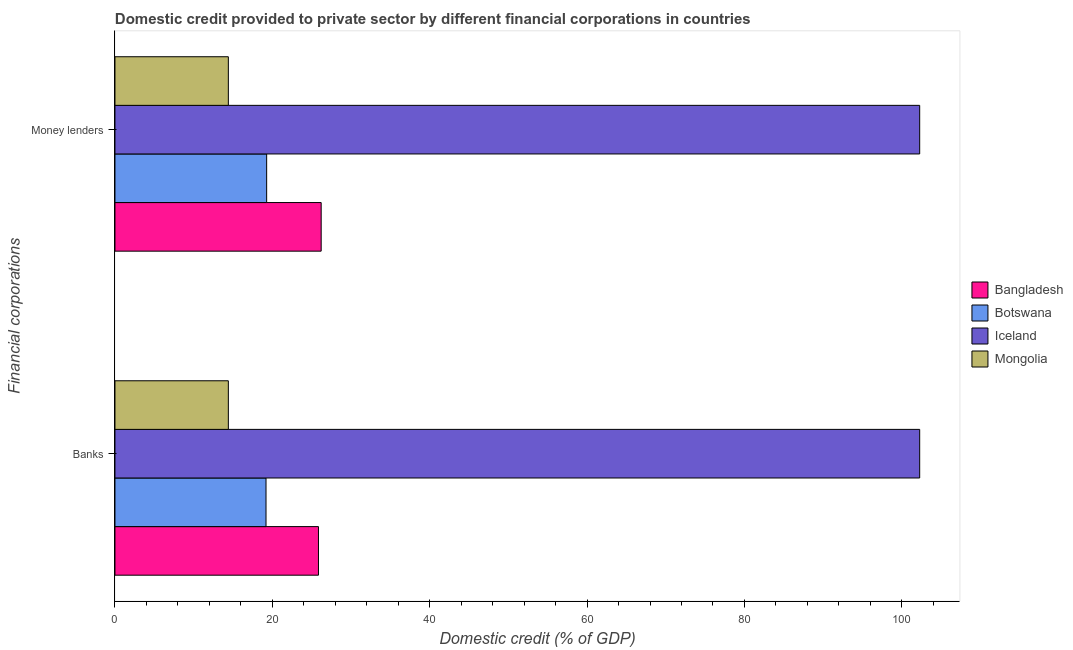How many different coloured bars are there?
Ensure brevity in your answer.  4. Are the number of bars per tick equal to the number of legend labels?
Your response must be concise. Yes. How many bars are there on the 2nd tick from the bottom?
Offer a terse response. 4. What is the label of the 1st group of bars from the top?
Offer a terse response. Money lenders. What is the domestic credit provided by money lenders in Bangladesh?
Your answer should be compact. 26.21. Across all countries, what is the maximum domestic credit provided by money lenders?
Make the answer very short. 102.27. Across all countries, what is the minimum domestic credit provided by money lenders?
Offer a very short reply. 14.41. In which country was the domestic credit provided by banks minimum?
Your response must be concise. Mongolia. What is the total domestic credit provided by banks in the graph?
Ensure brevity in your answer.  161.75. What is the difference between the domestic credit provided by money lenders in Mongolia and that in Iceland?
Your answer should be compact. -87.86. What is the difference between the domestic credit provided by money lenders in Mongolia and the domestic credit provided by banks in Bangladesh?
Your answer should be very brief. -11.45. What is the average domestic credit provided by banks per country?
Your answer should be compact. 40.44. What is the difference between the domestic credit provided by money lenders and domestic credit provided by banks in Botswana?
Make the answer very short. 0.08. In how many countries, is the domestic credit provided by money lenders greater than 80 %?
Your response must be concise. 1. What is the ratio of the domestic credit provided by banks in Iceland to that in Mongolia?
Give a very brief answer. 7.1. Is the domestic credit provided by money lenders in Mongolia less than that in Bangladesh?
Your answer should be very brief. Yes. What does the 3rd bar from the bottom in Money lenders represents?
Your answer should be very brief. Iceland. How many countries are there in the graph?
Provide a short and direct response. 4. What is the difference between two consecutive major ticks on the X-axis?
Your answer should be compact. 20. Are the values on the major ticks of X-axis written in scientific E-notation?
Your response must be concise. No. Does the graph contain any zero values?
Give a very brief answer. No. How many legend labels are there?
Offer a very short reply. 4. How are the legend labels stacked?
Ensure brevity in your answer.  Vertical. What is the title of the graph?
Give a very brief answer. Domestic credit provided to private sector by different financial corporations in countries. What is the label or title of the X-axis?
Your answer should be compact. Domestic credit (% of GDP). What is the label or title of the Y-axis?
Keep it short and to the point. Financial corporations. What is the Domestic credit (% of GDP) in Bangladesh in Banks?
Provide a succinct answer. 25.86. What is the Domestic credit (% of GDP) in Botswana in Banks?
Offer a terse response. 19.2. What is the Domestic credit (% of GDP) in Iceland in Banks?
Provide a short and direct response. 102.27. What is the Domestic credit (% of GDP) of Mongolia in Banks?
Provide a succinct answer. 14.41. What is the Domestic credit (% of GDP) of Bangladesh in Money lenders?
Give a very brief answer. 26.21. What is the Domestic credit (% of GDP) of Botswana in Money lenders?
Provide a succinct answer. 19.28. What is the Domestic credit (% of GDP) in Iceland in Money lenders?
Ensure brevity in your answer.  102.27. What is the Domestic credit (% of GDP) of Mongolia in Money lenders?
Keep it short and to the point. 14.41. Across all Financial corporations, what is the maximum Domestic credit (% of GDP) in Bangladesh?
Provide a short and direct response. 26.21. Across all Financial corporations, what is the maximum Domestic credit (% of GDP) of Botswana?
Your answer should be compact. 19.28. Across all Financial corporations, what is the maximum Domestic credit (% of GDP) in Iceland?
Offer a very short reply. 102.27. Across all Financial corporations, what is the maximum Domestic credit (% of GDP) of Mongolia?
Make the answer very short. 14.41. Across all Financial corporations, what is the minimum Domestic credit (% of GDP) in Bangladesh?
Keep it short and to the point. 25.86. Across all Financial corporations, what is the minimum Domestic credit (% of GDP) of Botswana?
Offer a very short reply. 19.2. Across all Financial corporations, what is the minimum Domestic credit (% of GDP) of Iceland?
Make the answer very short. 102.27. Across all Financial corporations, what is the minimum Domestic credit (% of GDP) in Mongolia?
Your answer should be compact. 14.41. What is the total Domestic credit (% of GDP) of Bangladesh in the graph?
Your response must be concise. 52.07. What is the total Domestic credit (% of GDP) of Botswana in the graph?
Offer a very short reply. 38.48. What is the total Domestic credit (% of GDP) of Iceland in the graph?
Ensure brevity in your answer.  204.55. What is the total Domestic credit (% of GDP) in Mongolia in the graph?
Make the answer very short. 28.82. What is the difference between the Domestic credit (% of GDP) of Bangladesh in Banks and that in Money lenders?
Provide a succinct answer. -0.34. What is the difference between the Domestic credit (% of GDP) of Botswana in Banks and that in Money lenders?
Your response must be concise. -0.08. What is the difference between the Domestic credit (% of GDP) of Mongolia in Banks and that in Money lenders?
Keep it short and to the point. 0. What is the difference between the Domestic credit (% of GDP) in Bangladesh in Banks and the Domestic credit (% of GDP) in Botswana in Money lenders?
Your answer should be very brief. 6.58. What is the difference between the Domestic credit (% of GDP) of Bangladesh in Banks and the Domestic credit (% of GDP) of Iceland in Money lenders?
Offer a very short reply. -76.41. What is the difference between the Domestic credit (% of GDP) of Bangladesh in Banks and the Domestic credit (% of GDP) of Mongolia in Money lenders?
Make the answer very short. 11.45. What is the difference between the Domestic credit (% of GDP) of Botswana in Banks and the Domestic credit (% of GDP) of Iceland in Money lenders?
Provide a succinct answer. -83.08. What is the difference between the Domestic credit (% of GDP) of Botswana in Banks and the Domestic credit (% of GDP) of Mongolia in Money lenders?
Provide a succinct answer. 4.79. What is the difference between the Domestic credit (% of GDP) in Iceland in Banks and the Domestic credit (% of GDP) in Mongolia in Money lenders?
Ensure brevity in your answer.  87.86. What is the average Domestic credit (% of GDP) of Bangladesh per Financial corporations?
Keep it short and to the point. 26.04. What is the average Domestic credit (% of GDP) of Botswana per Financial corporations?
Keep it short and to the point. 19.24. What is the average Domestic credit (% of GDP) in Iceland per Financial corporations?
Ensure brevity in your answer.  102.27. What is the average Domestic credit (% of GDP) in Mongolia per Financial corporations?
Keep it short and to the point. 14.41. What is the difference between the Domestic credit (% of GDP) of Bangladesh and Domestic credit (% of GDP) of Botswana in Banks?
Your answer should be very brief. 6.67. What is the difference between the Domestic credit (% of GDP) in Bangladesh and Domestic credit (% of GDP) in Iceland in Banks?
Provide a succinct answer. -76.41. What is the difference between the Domestic credit (% of GDP) in Bangladesh and Domestic credit (% of GDP) in Mongolia in Banks?
Your answer should be very brief. 11.45. What is the difference between the Domestic credit (% of GDP) of Botswana and Domestic credit (% of GDP) of Iceland in Banks?
Provide a succinct answer. -83.08. What is the difference between the Domestic credit (% of GDP) in Botswana and Domestic credit (% of GDP) in Mongolia in Banks?
Make the answer very short. 4.79. What is the difference between the Domestic credit (% of GDP) in Iceland and Domestic credit (% of GDP) in Mongolia in Banks?
Provide a short and direct response. 87.86. What is the difference between the Domestic credit (% of GDP) in Bangladesh and Domestic credit (% of GDP) in Botswana in Money lenders?
Your response must be concise. 6.93. What is the difference between the Domestic credit (% of GDP) of Bangladesh and Domestic credit (% of GDP) of Iceland in Money lenders?
Provide a succinct answer. -76.07. What is the difference between the Domestic credit (% of GDP) in Bangladesh and Domestic credit (% of GDP) in Mongolia in Money lenders?
Offer a very short reply. 11.8. What is the difference between the Domestic credit (% of GDP) in Botswana and Domestic credit (% of GDP) in Iceland in Money lenders?
Your answer should be very brief. -82.99. What is the difference between the Domestic credit (% of GDP) in Botswana and Domestic credit (% of GDP) in Mongolia in Money lenders?
Your answer should be very brief. 4.87. What is the difference between the Domestic credit (% of GDP) of Iceland and Domestic credit (% of GDP) of Mongolia in Money lenders?
Make the answer very short. 87.86. What is the ratio of the Domestic credit (% of GDP) of Bangladesh in Banks to that in Money lenders?
Keep it short and to the point. 0.99. What is the ratio of the Domestic credit (% of GDP) of Botswana in Banks to that in Money lenders?
Provide a short and direct response. 1. What is the difference between the highest and the second highest Domestic credit (% of GDP) of Bangladesh?
Provide a succinct answer. 0.34. What is the difference between the highest and the second highest Domestic credit (% of GDP) of Botswana?
Offer a terse response. 0.08. What is the difference between the highest and the second highest Domestic credit (% of GDP) in Mongolia?
Keep it short and to the point. 0. What is the difference between the highest and the lowest Domestic credit (% of GDP) in Bangladesh?
Provide a succinct answer. 0.34. What is the difference between the highest and the lowest Domestic credit (% of GDP) in Botswana?
Ensure brevity in your answer.  0.08. 